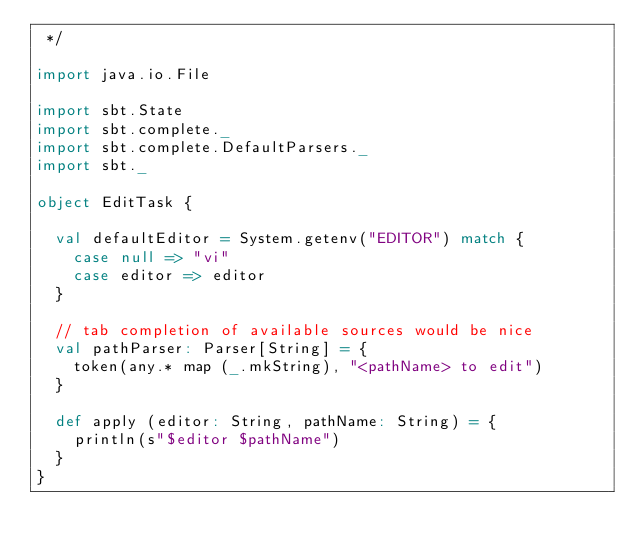<code> <loc_0><loc_0><loc_500><loc_500><_Scala_> */

import java.io.File

import sbt.State
import sbt.complete._
import sbt.complete.DefaultParsers._
import sbt._

object EditTask {

  val defaultEditor = System.getenv("EDITOR") match {
    case null => "vi"
    case editor => editor
  }

  // tab completion of available sources would be nice
  val pathParser: Parser[String] = {
    token(any.* map (_.mkString), "<pathName> to edit")
  }

  def apply (editor: String, pathName: String) = {
    println(s"$editor $pathName")
  }
}</code> 